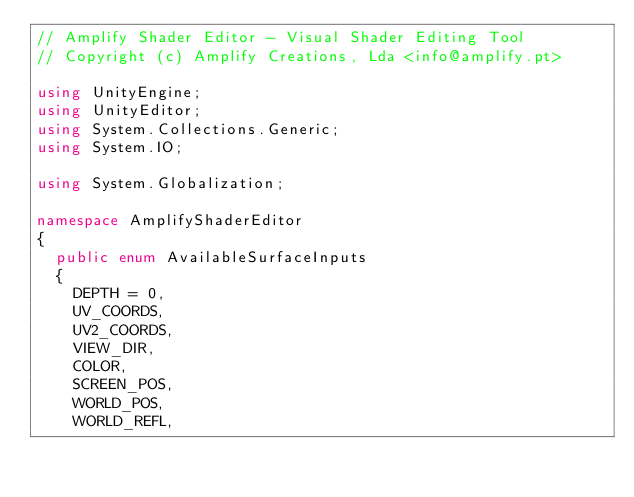<code> <loc_0><loc_0><loc_500><loc_500><_C#_>// Amplify Shader Editor - Visual Shader Editing Tool
// Copyright (c) Amplify Creations, Lda <info@amplify.pt>

using UnityEngine;
using UnityEditor;
using System.Collections.Generic;
using System.IO;

using System.Globalization;

namespace AmplifyShaderEditor
{
	public enum AvailableSurfaceInputs
	{
		DEPTH = 0,
		UV_COORDS,
		UV2_COORDS,
		VIEW_DIR,
		COLOR,
		SCREEN_POS,
		WORLD_POS,
		WORLD_REFL,</code> 